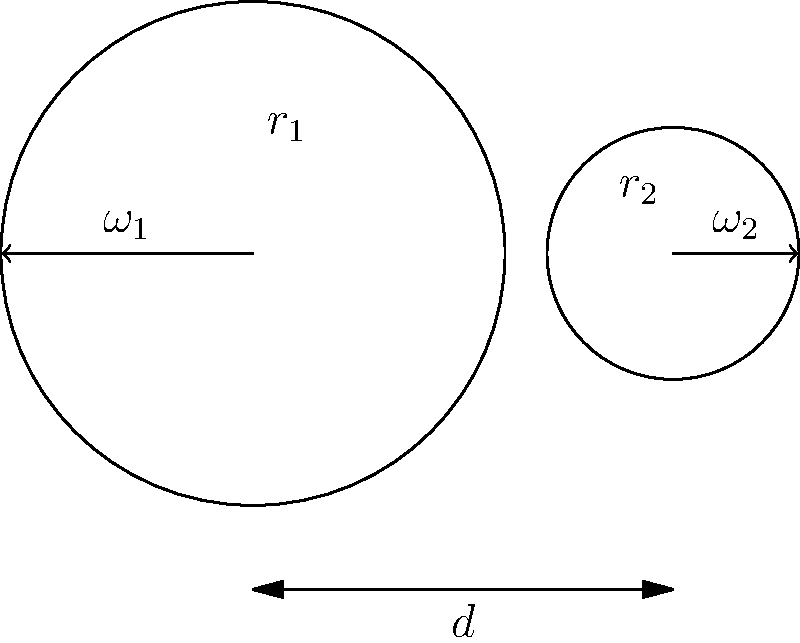In an electric wheelchair's gear mechanism, two gears are in contact as shown in the diagram. The larger gear (Gear 1) has a radius $r_1 = 3$ cm and rotates at $\omega_1 = 20$ rpm. If the smaller gear (Gear 2) has a radius $r_2 = 1.5$ cm, what is the angular velocity $\omega_2$ of Gear 2 in rpm? To solve this problem, we'll use the principle of gear ratios and angular velocity relationships:

1. The gear ratio is inversely proportional to the ratio of angular velocities:
   $$\frac{r_1}{r_2} = \frac{\omega_2}{\omega_1}$$

2. We know:
   $r_1 = 3$ cm
   $r_2 = 1.5$ cm
   $\omega_1 = 20$ rpm

3. Substituting these values into the equation:
   $$\frac{3}{1.5} = \frac{\omega_2}{20}$$

4. Simplify the left side:
   $$2 = \frac{\omega_2}{20}$$

5. Multiply both sides by 20:
   $$40 = \omega_2$$

Therefore, the angular velocity of Gear 2 ($\omega_2$) is 40 rpm.
Answer: 40 rpm 